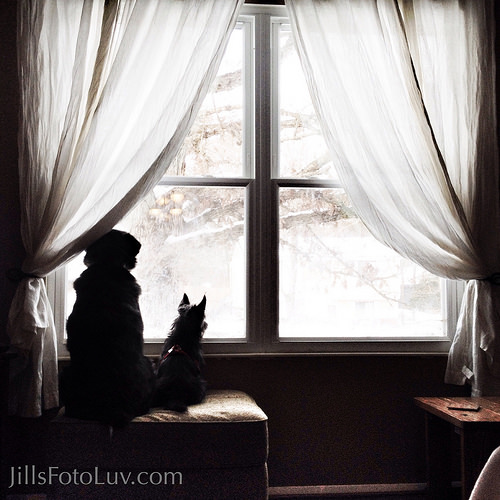<image>
Is there a dog in front of the tree? No. The dog is not in front of the tree. The spatial positioning shows a different relationship between these objects. 